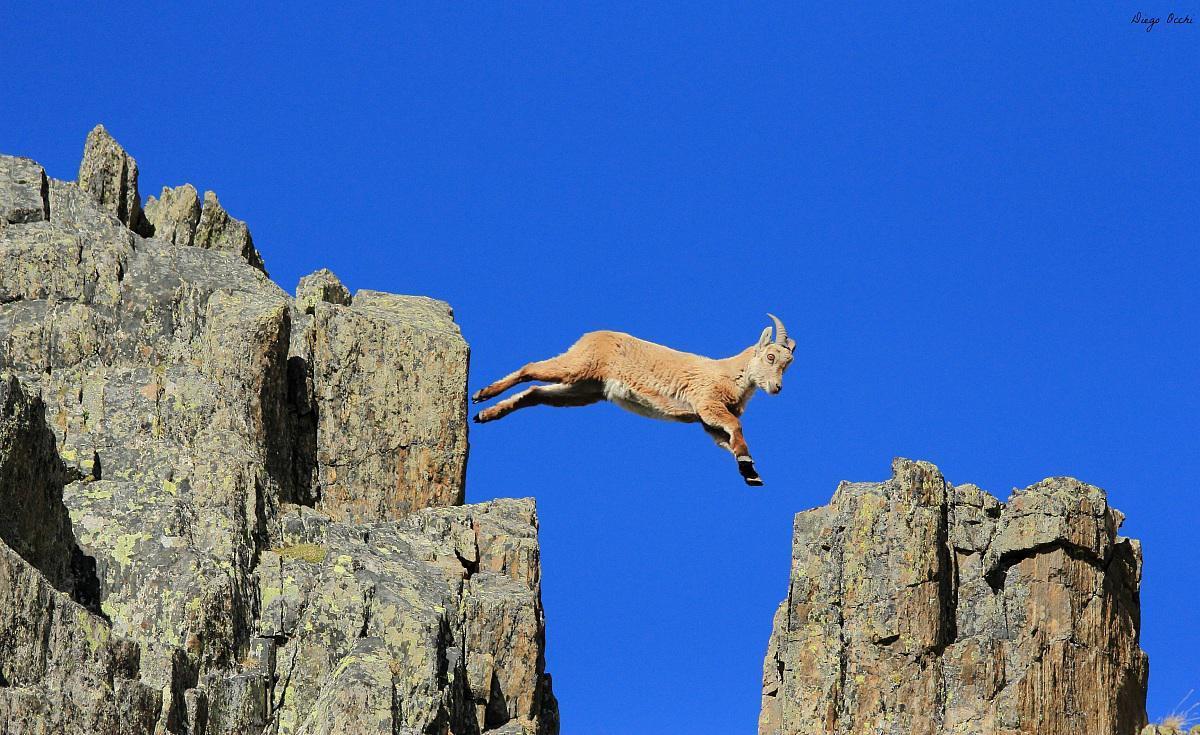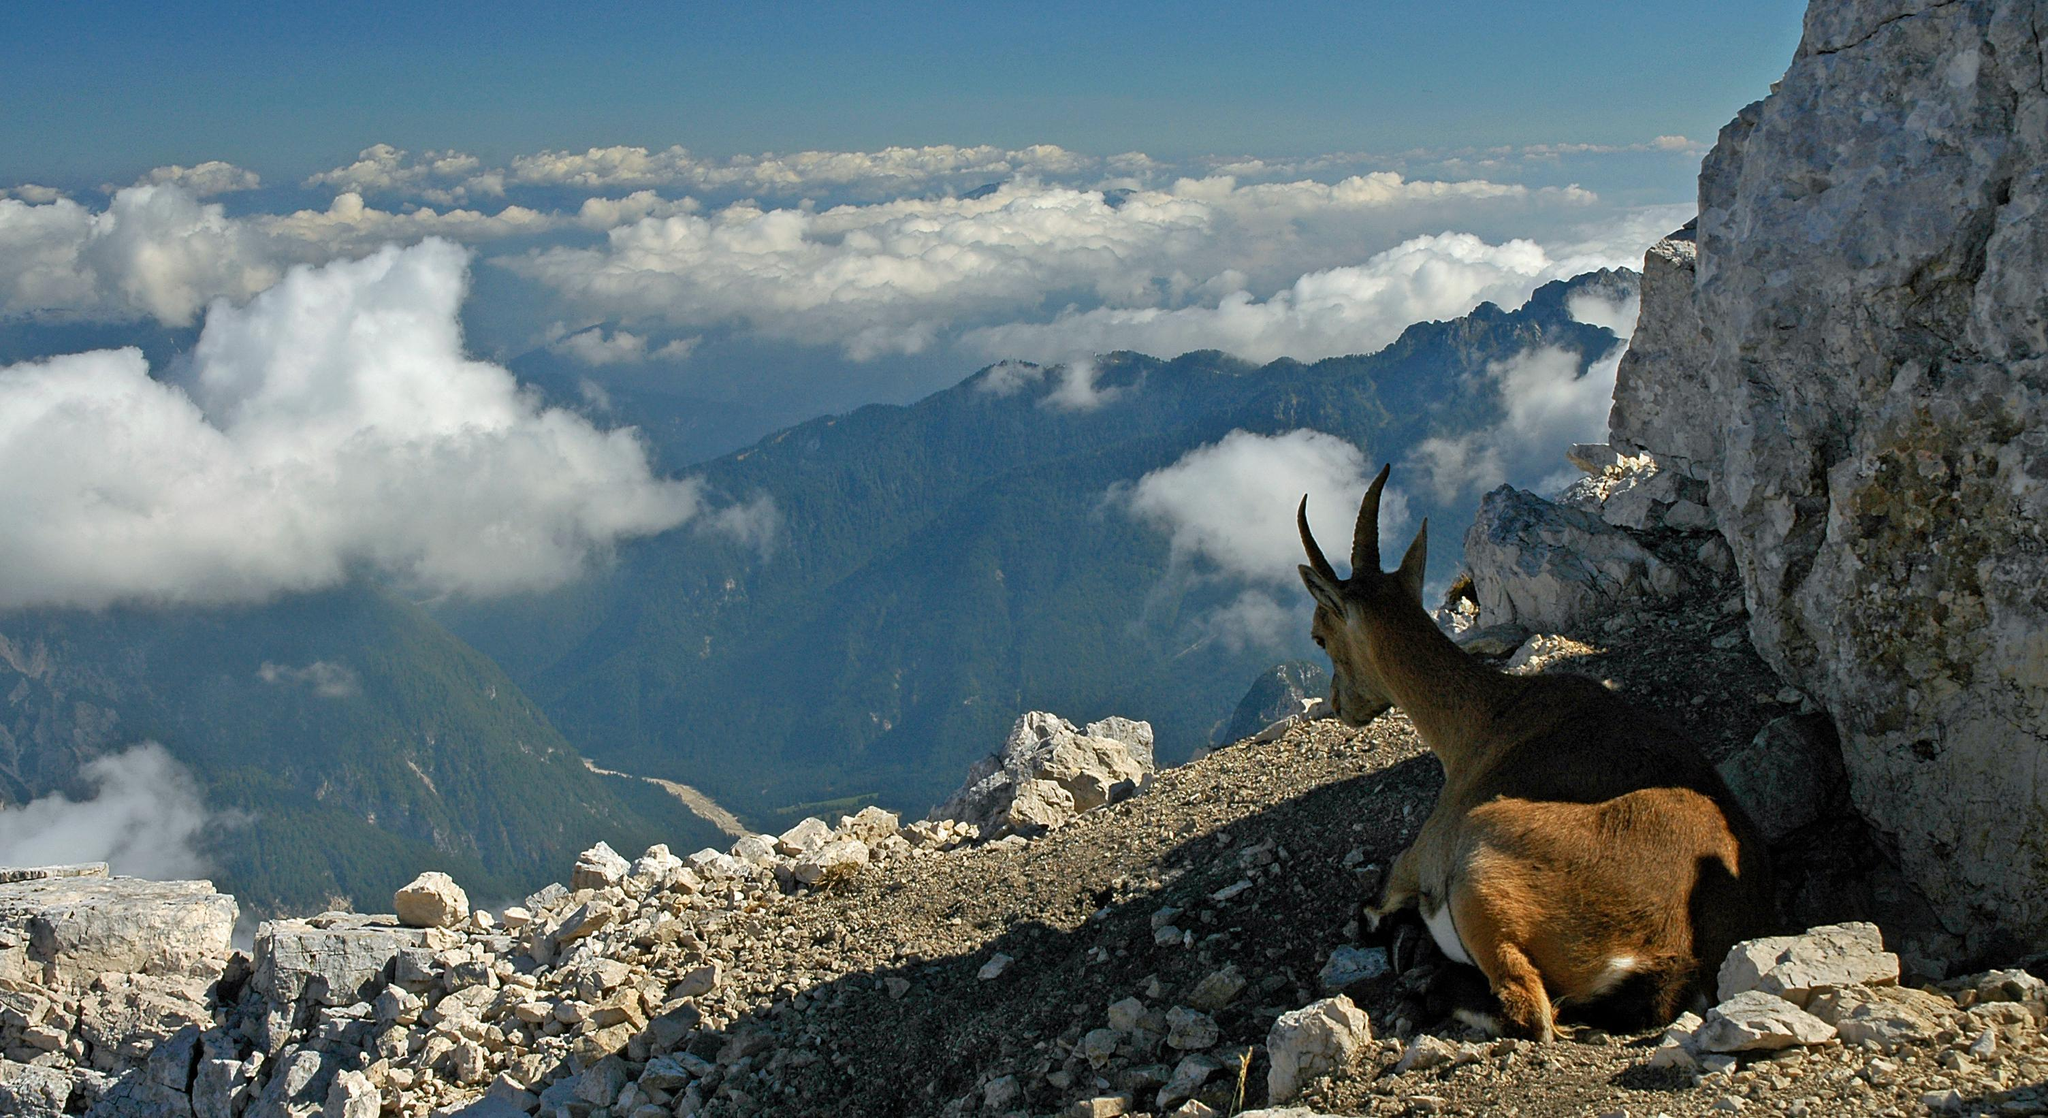The first image is the image on the left, the second image is the image on the right. For the images shown, is this caption "All images have a blue background; not a cloud in the sky." true? Answer yes or no. No. The first image is the image on the left, the second image is the image on the right. Assess this claim about the two images: "The left image shows one horned animal standing on an inclined rock surface.". Correct or not? Answer yes or no. No. 